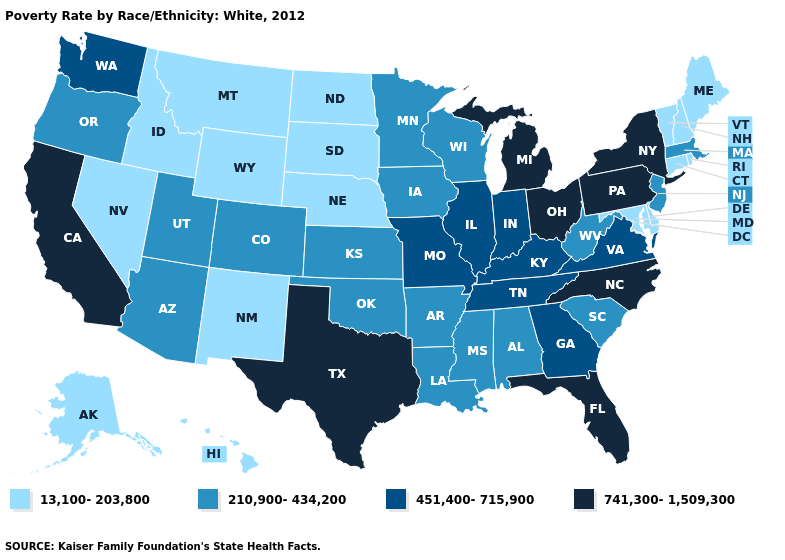What is the highest value in the MidWest ?
Short answer required. 741,300-1,509,300. Which states hav the highest value in the Northeast?
Give a very brief answer. New York, Pennsylvania. Which states have the highest value in the USA?
Keep it brief. California, Florida, Michigan, New York, North Carolina, Ohio, Pennsylvania, Texas. What is the highest value in the USA?
Give a very brief answer. 741,300-1,509,300. Among the states that border Arkansas , which have the lowest value?
Give a very brief answer. Louisiana, Mississippi, Oklahoma. How many symbols are there in the legend?
Concise answer only. 4. How many symbols are there in the legend?
Answer briefly. 4. Name the states that have a value in the range 210,900-434,200?
Write a very short answer. Alabama, Arizona, Arkansas, Colorado, Iowa, Kansas, Louisiana, Massachusetts, Minnesota, Mississippi, New Jersey, Oklahoma, Oregon, South Carolina, Utah, West Virginia, Wisconsin. Name the states that have a value in the range 451,400-715,900?
Write a very short answer. Georgia, Illinois, Indiana, Kentucky, Missouri, Tennessee, Virginia, Washington. Does the first symbol in the legend represent the smallest category?
Give a very brief answer. Yes. What is the value of Minnesota?
Quick response, please. 210,900-434,200. What is the lowest value in states that border Nebraska?
Quick response, please. 13,100-203,800. What is the lowest value in states that border Illinois?
Be succinct. 210,900-434,200. Does the first symbol in the legend represent the smallest category?
Keep it brief. Yes. What is the value of Nebraska?
Write a very short answer. 13,100-203,800. 